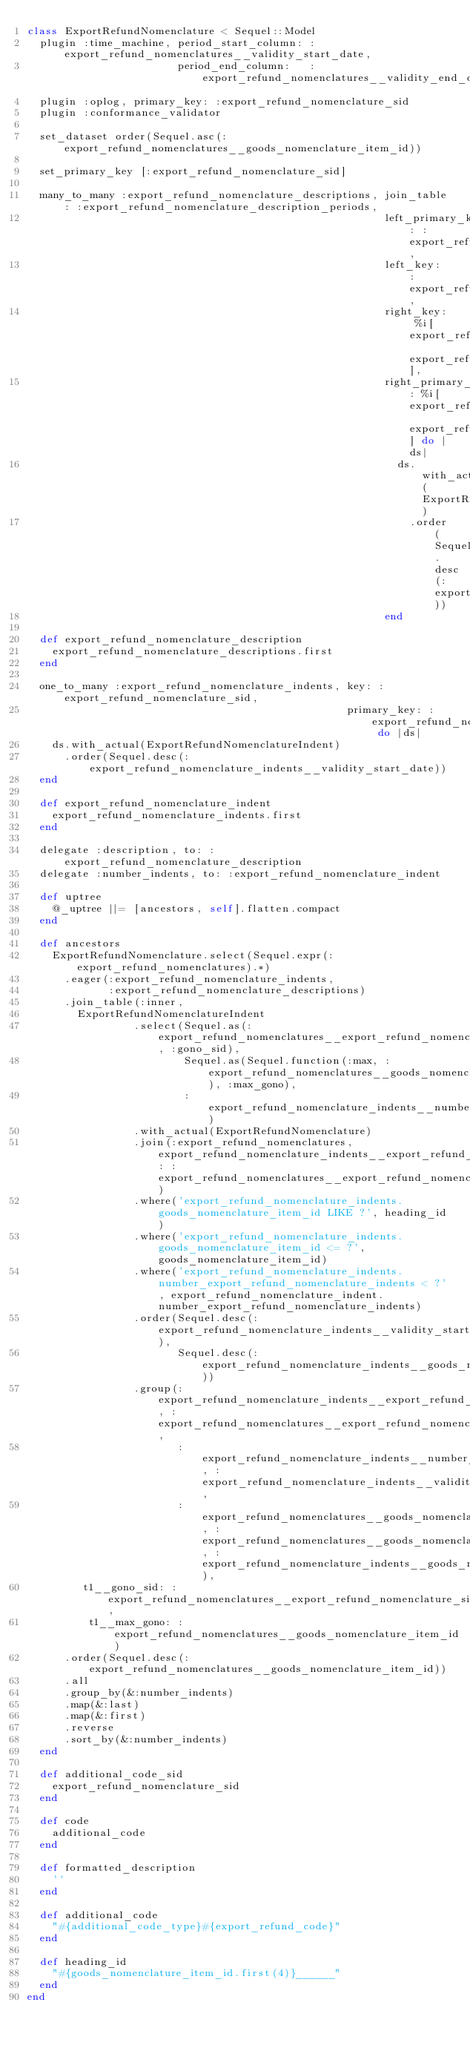<code> <loc_0><loc_0><loc_500><loc_500><_Ruby_>class ExportRefundNomenclature < Sequel::Model
  plugin :time_machine, period_start_column: :export_refund_nomenclatures__validity_start_date,
                        period_end_column:   :export_refund_nomenclatures__validity_end_date
  plugin :oplog, primary_key: :export_refund_nomenclature_sid
  plugin :conformance_validator

  set_dataset order(Sequel.asc(:export_refund_nomenclatures__goods_nomenclature_item_id))

  set_primary_key [:export_refund_nomenclature_sid]

  many_to_many :export_refund_nomenclature_descriptions, join_table: :export_refund_nomenclature_description_periods,
                                                         left_primary_key: :export_refund_nomenclature_sid,
                                                         left_key: :export_refund_nomenclature_sid,
                                                         right_key: %i[export_refund_nomenclature_description_period_sid export_refund_nomenclature_sid],
                                                         right_primary_key: %i[export_refund_nomenclature_description_period_sid export_refund_nomenclature_sid] do |ds|
                                                           ds.with_actual(ExportRefundNomenclatureDescriptionPeriod)
                                                             .order(Sequel.desc(:export_refund_nomenclature_description_periods__validity_start_date))
                                                         end

  def export_refund_nomenclature_description
    export_refund_nomenclature_descriptions.first
  end

  one_to_many :export_refund_nomenclature_indents, key: :export_refund_nomenclature_sid,
                                                   primary_key: :export_refund_nomenclature_sid do |ds|
    ds.with_actual(ExportRefundNomenclatureIndent)
      .order(Sequel.desc(:export_refund_nomenclature_indents__validity_start_date))
  end

  def export_refund_nomenclature_indent
    export_refund_nomenclature_indents.first
  end

  delegate :description, to: :export_refund_nomenclature_description
  delegate :number_indents, to: :export_refund_nomenclature_indent

  def uptree
    @_uptree ||= [ancestors, self].flatten.compact
  end

  def ancestors
    ExportRefundNomenclature.select(Sequel.expr(:export_refund_nomenclatures).*)
      .eager(:export_refund_nomenclature_indents,
             :export_refund_nomenclature_descriptions)
      .join_table(:inner,
        ExportRefundNomenclatureIndent
                 .select(Sequel.as(:export_refund_nomenclatures__export_refund_nomenclature_sid, :gono_sid),
                         Sequel.as(Sequel.function(:max, :export_refund_nomenclatures__goods_nomenclature_item_id), :max_gono),
                         :export_refund_nomenclature_indents__number_export_refund_nomenclature_indents)
                 .with_actual(ExportRefundNomenclature)
                 .join(:export_refund_nomenclatures, export_refund_nomenclature_indents__export_refund_nomenclature_sid: :export_refund_nomenclatures__export_refund_nomenclature_sid)
                 .where('export_refund_nomenclature_indents.goods_nomenclature_item_id LIKE ?', heading_id)
                 .where('export_refund_nomenclature_indents.goods_nomenclature_item_id <= ?', goods_nomenclature_item_id)
                 .where('export_refund_nomenclature_indents.number_export_refund_nomenclature_indents < ?', export_refund_nomenclature_indent.number_export_refund_nomenclature_indents)
                 .order(Sequel.desc(:export_refund_nomenclature_indents__validity_start_date),
                        Sequel.desc(:export_refund_nomenclature_indents__goods_nomenclature_item_id))
                 .group(:export_refund_nomenclature_indents__export_refund_nomenclature_sid, :export_refund_nomenclatures__export_refund_nomenclature_sid,
                        :export_refund_nomenclature_indents__number_export_refund_nomenclature_indents, :export_refund_nomenclature_indents__validity_start_date,
                        :export_refund_nomenclatures__goods_nomenclature_item_id, :export_refund_nomenclatures__goods_nomenclature_item_id, :export_refund_nomenclature_indents__goods_nomenclature_item_id),
         t1__gono_sid: :export_refund_nomenclatures__export_refund_nomenclature_sid,
          t1__max_gono: :export_refund_nomenclatures__goods_nomenclature_item_id)
      .order(Sequel.desc(:export_refund_nomenclatures__goods_nomenclature_item_id))
      .all
      .group_by(&:number_indents)
      .map(&:last)
      .map(&:first)
      .reverse
      .sort_by(&:number_indents)
  end

  def additional_code_sid
    export_refund_nomenclature_sid
  end

  def code
    additional_code
  end
  
  def formatted_description
    ''
  end

  def additional_code
    "#{additional_code_type}#{export_refund_code}"
  end

  def heading_id
    "#{goods_nomenclature_item_id.first(4)}______"
  end
end
</code> 